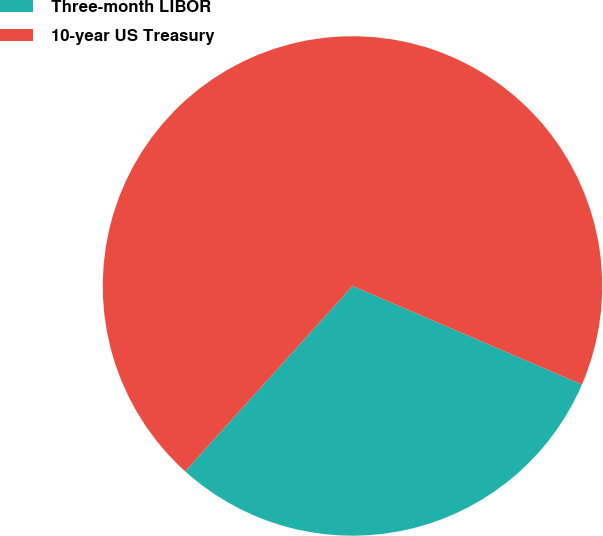Convert chart. <chart><loc_0><loc_0><loc_500><loc_500><pie_chart><fcel>Three-month LIBOR<fcel>10-year US Treasury<nl><fcel>30.23%<fcel>69.77%<nl></chart> 